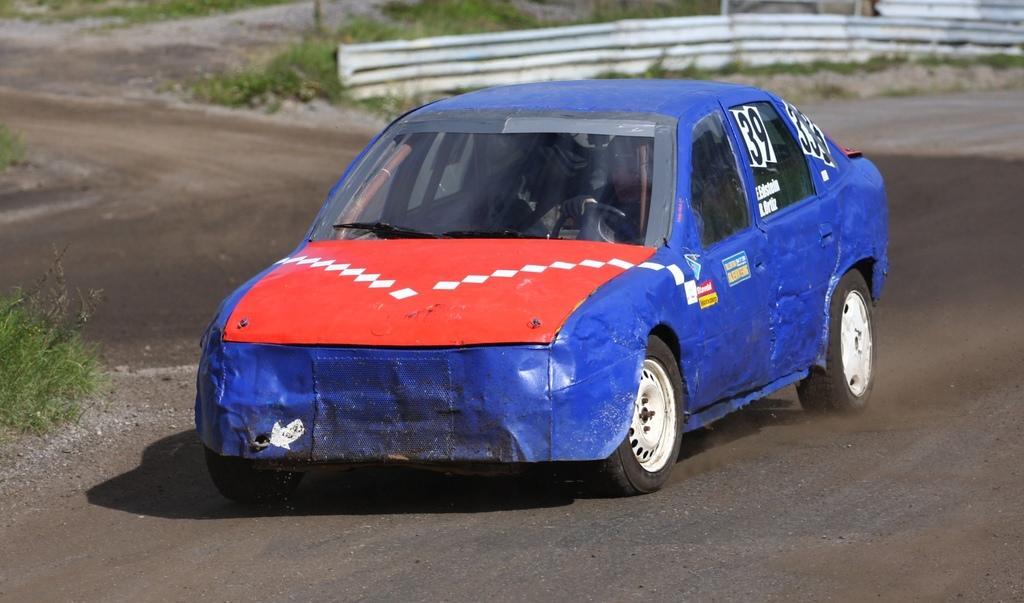How would you summarize this image in a sentence or two? In this image there is a blue and red color race car on the road, and in the background there are plants and iron sheets. 